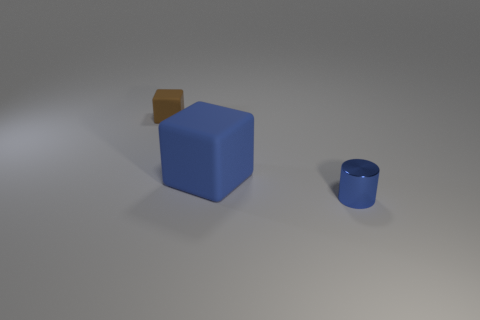Add 1 blue rubber cubes. How many objects exist? 4 Subtract all cylinders. How many objects are left? 2 Add 1 big blue metallic cylinders. How many big blue metallic cylinders exist? 1 Subtract 1 blue cylinders. How many objects are left? 2 Subtract all green cylinders. Subtract all blue metal cylinders. How many objects are left? 2 Add 2 small cylinders. How many small cylinders are left? 3 